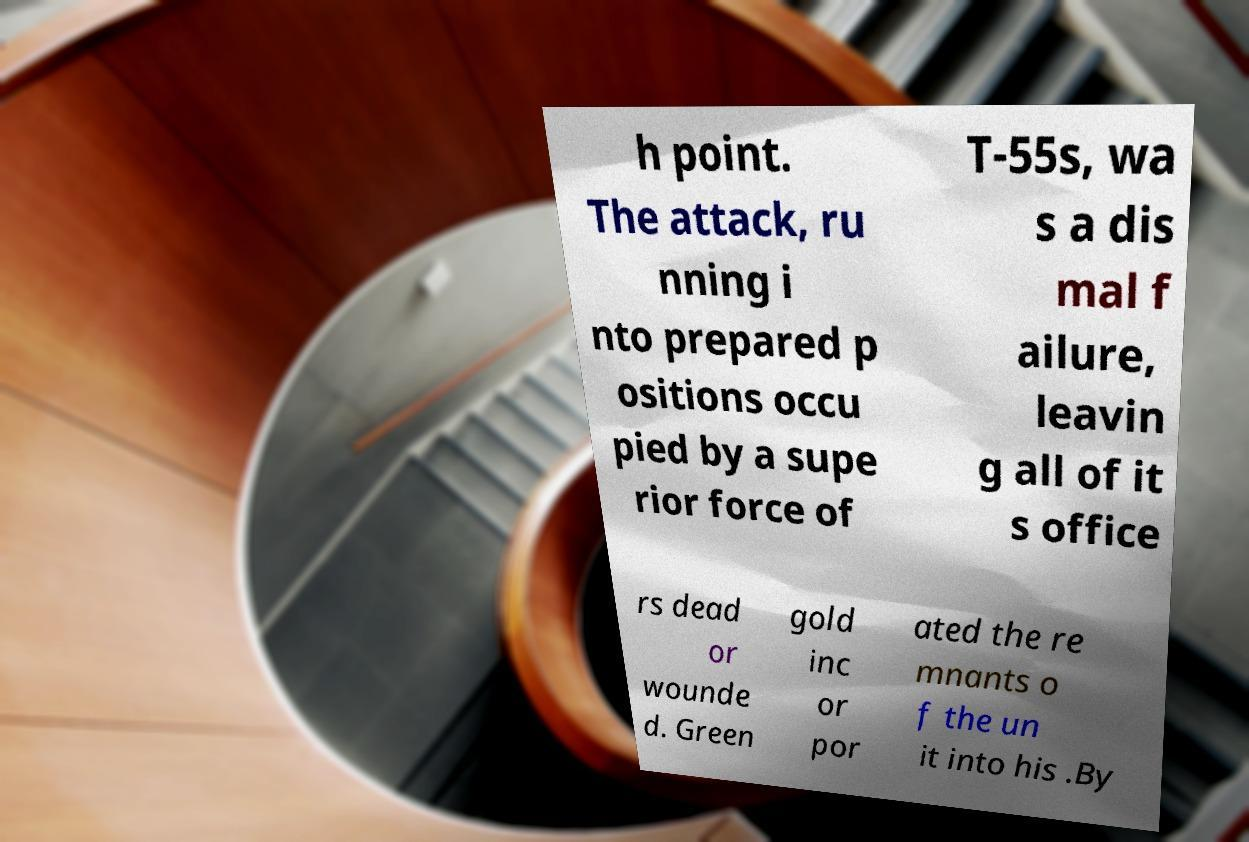Please read and relay the text visible in this image. What does it say? h point. The attack, ru nning i nto prepared p ositions occu pied by a supe rior force of T-55s, wa s a dis mal f ailure, leavin g all of it s office rs dead or wounde d. Green gold inc or por ated the re mnants o f the un it into his .By 